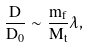<formula> <loc_0><loc_0><loc_500><loc_500>\frac { D } { D _ { 0 } } \sim \frac { m _ { f } } { M _ { t } } \lambda ,</formula> 